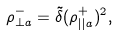Convert formula to latex. <formula><loc_0><loc_0><loc_500><loc_500>\rho _ { \perp a } ^ { - } = \tilde { \delta } ( { \rho _ { | | a } ^ { + } } ) ^ { 2 } ,</formula> 